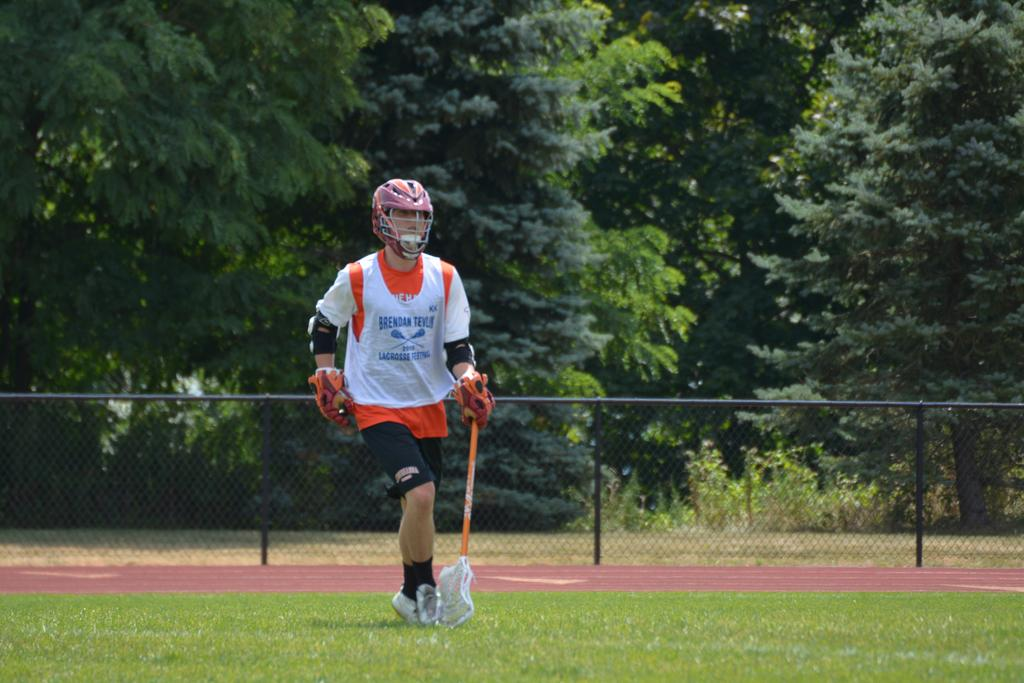<image>
Render a clear and concise summary of the photo. a man with a mask and the name Brendan on his shirt 